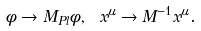Convert formula to latex. <formula><loc_0><loc_0><loc_500><loc_500>\phi \to M _ { P l } \phi , \ x ^ { \mu } \to M ^ { - 1 } x ^ { \mu } .</formula> 